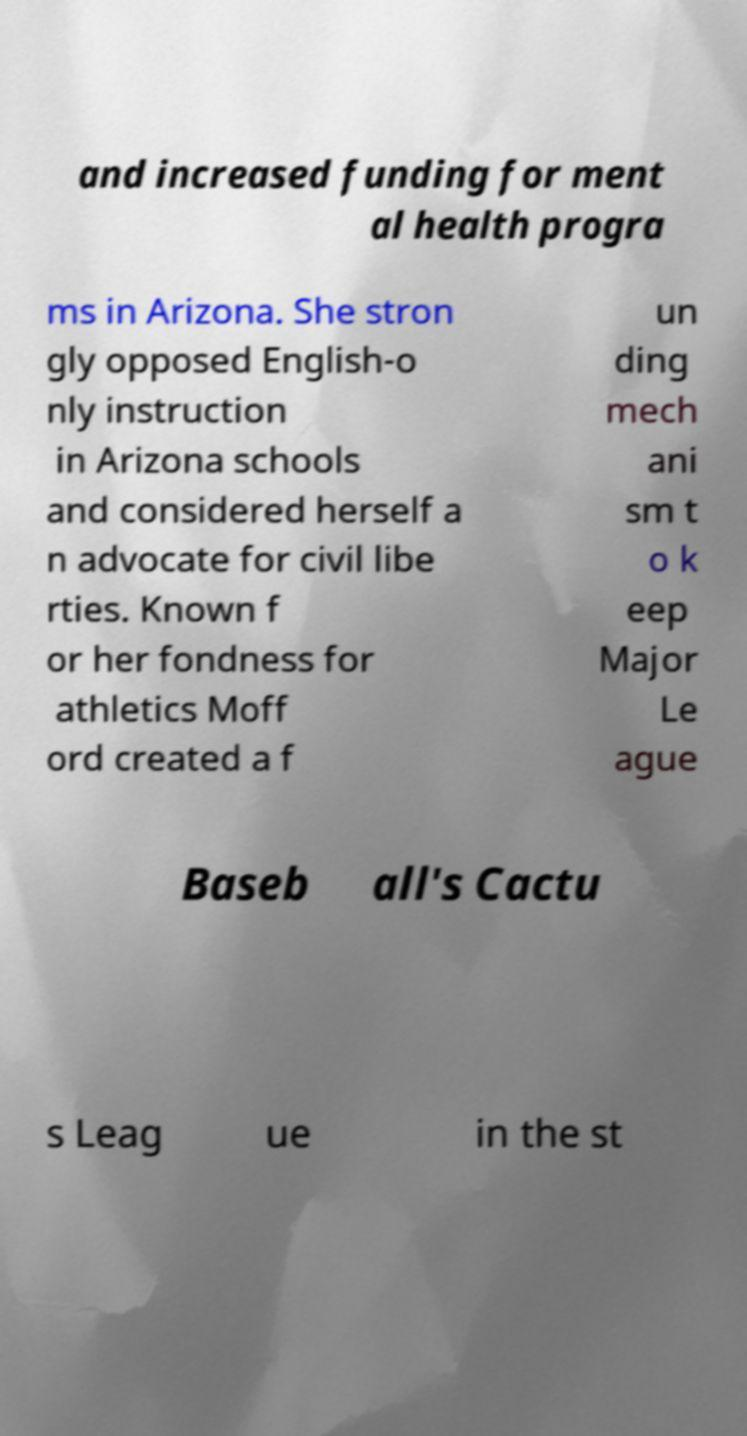Please read and relay the text visible in this image. What does it say? and increased funding for ment al health progra ms in Arizona. She stron gly opposed English-o nly instruction in Arizona schools and considered herself a n advocate for civil libe rties. Known f or her fondness for athletics Moff ord created a f un ding mech ani sm t o k eep Major Le ague Baseb all's Cactu s Leag ue in the st 